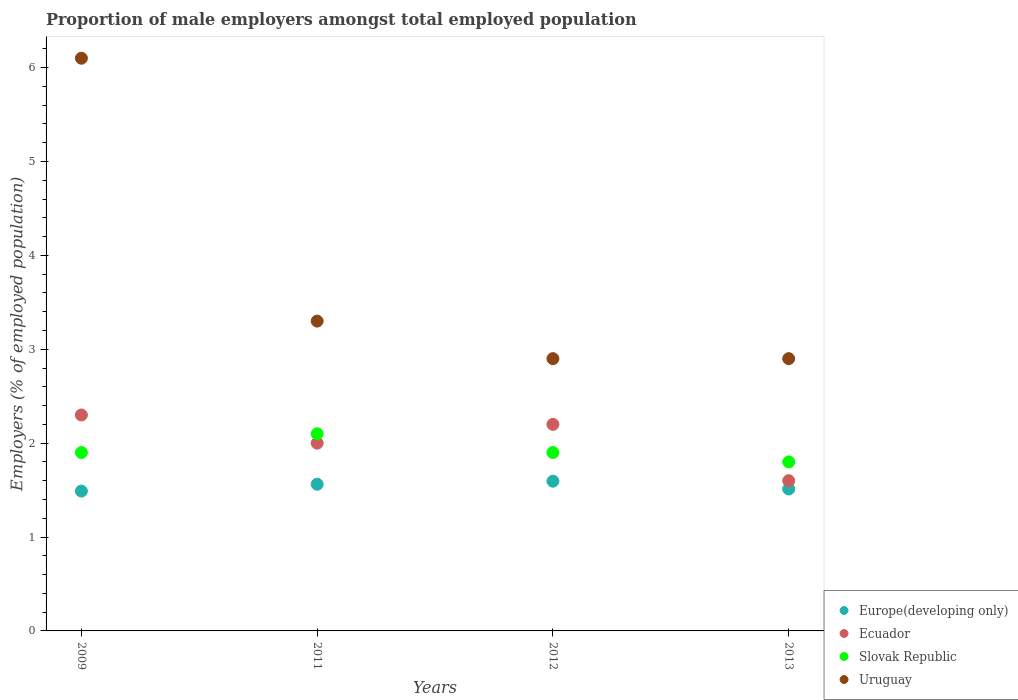What is the proportion of male employers in Uruguay in 2011?
Give a very brief answer. 3.3. Across all years, what is the maximum proportion of male employers in Ecuador?
Your response must be concise. 2.3. Across all years, what is the minimum proportion of male employers in Uruguay?
Provide a short and direct response. 2.9. In which year was the proportion of male employers in Slovak Republic maximum?
Your answer should be compact. 2011. In which year was the proportion of male employers in Ecuador minimum?
Keep it short and to the point. 2013. What is the total proportion of male employers in Uruguay in the graph?
Give a very brief answer. 15.2. What is the difference between the proportion of male employers in Europe(developing only) in 2009 and that in 2011?
Your answer should be compact. -0.07. What is the difference between the proportion of male employers in Slovak Republic in 2011 and the proportion of male employers in Ecuador in 2013?
Make the answer very short. 0.5. What is the average proportion of male employers in Slovak Republic per year?
Offer a very short reply. 1.92. In the year 2013, what is the difference between the proportion of male employers in Slovak Republic and proportion of male employers in Ecuador?
Your response must be concise. 0.2. What is the ratio of the proportion of male employers in Europe(developing only) in 2009 to that in 2013?
Offer a very short reply. 0.99. What is the difference between the highest and the second highest proportion of male employers in Uruguay?
Give a very brief answer. 2.8. What is the difference between the highest and the lowest proportion of male employers in Ecuador?
Ensure brevity in your answer.  0.7. Is the sum of the proportion of male employers in Ecuador in 2009 and 2012 greater than the maximum proportion of male employers in Slovak Republic across all years?
Your answer should be compact. Yes. Is it the case that in every year, the sum of the proportion of male employers in Slovak Republic and proportion of male employers in Ecuador  is greater than the sum of proportion of male employers in Uruguay and proportion of male employers in Europe(developing only)?
Ensure brevity in your answer.  No. Does the proportion of male employers in Slovak Republic monotonically increase over the years?
Keep it short and to the point. No. Is the proportion of male employers in Slovak Republic strictly less than the proportion of male employers in Europe(developing only) over the years?
Provide a succinct answer. No. How many dotlines are there?
Ensure brevity in your answer.  4. Are the values on the major ticks of Y-axis written in scientific E-notation?
Your answer should be very brief. No. Does the graph contain grids?
Keep it short and to the point. No. Where does the legend appear in the graph?
Make the answer very short. Bottom right. How many legend labels are there?
Offer a terse response. 4. What is the title of the graph?
Ensure brevity in your answer.  Proportion of male employers amongst total employed population. Does "Euro area" appear as one of the legend labels in the graph?
Ensure brevity in your answer.  No. What is the label or title of the Y-axis?
Your response must be concise. Employers (% of employed population). What is the Employers (% of employed population) in Europe(developing only) in 2009?
Make the answer very short. 1.49. What is the Employers (% of employed population) of Ecuador in 2009?
Provide a succinct answer. 2.3. What is the Employers (% of employed population) of Slovak Republic in 2009?
Make the answer very short. 1.9. What is the Employers (% of employed population) in Uruguay in 2009?
Offer a very short reply. 6.1. What is the Employers (% of employed population) in Europe(developing only) in 2011?
Your response must be concise. 1.56. What is the Employers (% of employed population) of Ecuador in 2011?
Offer a terse response. 2. What is the Employers (% of employed population) in Slovak Republic in 2011?
Provide a succinct answer. 2.1. What is the Employers (% of employed population) in Uruguay in 2011?
Ensure brevity in your answer.  3.3. What is the Employers (% of employed population) of Europe(developing only) in 2012?
Provide a short and direct response. 1.59. What is the Employers (% of employed population) in Ecuador in 2012?
Offer a very short reply. 2.2. What is the Employers (% of employed population) in Slovak Republic in 2012?
Offer a very short reply. 1.9. What is the Employers (% of employed population) in Uruguay in 2012?
Give a very brief answer. 2.9. What is the Employers (% of employed population) of Europe(developing only) in 2013?
Make the answer very short. 1.51. What is the Employers (% of employed population) in Ecuador in 2013?
Your answer should be very brief. 1.6. What is the Employers (% of employed population) of Slovak Republic in 2013?
Your answer should be compact. 1.8. What is the Employers (% of employed population) of Uruguay in 2013?
Your response must be concise. 2.9. Across all years, what is the maximum Employers (% of employed population) of Europe(developing only)?
Your answer should be very brief. 1.59. Across all years, what is the maximum Employers (% of employed population) of Ecuador?
Your answer should be compact. 2.3. Across all years, what is the maximum Employers (% of employed population) in Slovak Republic?
Offer a very short reply. 2.1. Across all years, what is the maximum Employers (% of employed population) of Uruguay?
Ensure brevity in your answer.  6.1. Across all years, what is the minimum Employers (% of employed population) of Europe(developing only)?
Provide a succinct answer. 1.49. Across all years, what is the minimum Employers (% of employed population) of Ecuador?
Your answer should be very brief. 1.6. Across all years, what is the minimum Employers (% of employed population) of Slovak Republic?
Keep it short and to the point. 1.8. Across all years, what is the minimum Employers (% of employed population) in Uruguay?
Your response must be concise. 2.9. What is the total Employers (% of employed population) in Europe(developing only) in the graph?
Give a very brief answer. 6.16. What is the total Employers (% of employed population) of Ecuador in the graph?
Your response must be concise. 8.1. What is the difference between the Employers (% of employed population) in Europe(developing only) in 2009 and that in 2011?
Make the answer very short. -0.07. What is the difference between the Employers (% of employed population) of Europe(developing only) in 2009 and that in 2012?
Your response must be concise. -0.11. What is the difference between the Employers (% of employed population) of Europe(developing only) in 2009 and that in 2013?
Your answer should be very brief. -0.02. What is the difference between the Employers (% of employed population) of Ecuador in 2009 and that in 2013?
Your answer should be compact. 0.7. What is the difference between the Employers (% of employed population) in Slovak Republic in 2009 and that in 2013?
Your answer should be very brief. 0.1. What is the difference between the Employers (% of employed population) in Uruguay in 2009 and that in 2013?
Give a very brief answer. 3.2. What is the difference between the Employers (% of employed population) in Europe(developing only) in 2011 and that in 2012?
Keep it short and to the point. -0.03. What is the difference between the Employers (% of employed population) in Ecuador in 2011 and that in 2012?
Offer a very short reply. -0.2. What is the difference between the Employers (% of employed population) in Slovak Republic in 2011 and that in 2012?
Make the answer very short. 0.2. What is the difference between the Employers (% of employed population) of Uruguay in 2011 and that in 2012?
Your response must be concise. 0.4. What is the difference between the Employers (% of employed population) of Europe(developing only) in 2011 and that in 2013?
Ensure brevity in your answer.  0.05. What is the difference between the Employers (% of employed population) of Slovak Republic in 2011 and that in 2013?
Provide a short and direct response. 0.3. What is the difference between the Employers (% of employed population) of Europe(developing only) in 2012 and that in 2013?
Your answer should be very brief. 0.08. What is the difference between the Employers (% of employed population) in Slovak Republic in 2012 and that in 2013?
Offer a terse response. 0.1. What is the difference between the Employers (% of employed population) of Uruguay in 2012 and that in 2013?
Keep it short and to the point. 0. What is the difference between the Employers (% of employed population) in Europe(developing only) in 2009 and the Employers (% of employed population) in Ecuador in 2011?
Your response must be concise. -0.51. What is the difference between the Employers (% of employed population) of Europe(developing only) in 2009 and the Employers (% of employed population) of Slovak Republic in 2011?
Provide a short and direct response. -0.61. What is the difference between the Employers (% of employed population) in Europe(developing only) in 2009 and the Employers (% of employed population) in Uruguay in 2011?
Your answer should be very brief. -1.81. What is the difference between the Employers (% of employed population) of Europe(developing only) in 2009 and the Employers (% of employed population) of Ecuador in 2012?
Offer a very short reply. -0.71. What is the difference between the Employers (% of employed population) of Europe(developing only) in 2009 and the Employers (% of employed population) of Slovak Republic in 2012?
Provide a short and direct response. -0.41. What is the difference between the Employers (% of employed population) in Europe(developing only) in 2009 and the Employers (% of employed population) in Uruguay in 2012?
Ensure brevity in your answer.  -1.41. What is the difference between the Employers (% of employed population) in Ecuador in 2009 and the Employers (% of employed population) in Slovak Republic in 2012?
Ensure brevity in your answer.  0.4. What is the difference between the Employers (% of employed population) in Slovak Republic in 2009 and the Employers (% of employed population) in Uruguay in 2012?
Make the answer very short. -1. What is the difference between the Employers (% of employed population) of Europe(developing only) in 2009 and the Employers (% of employed population) of Ecuador in 2013?
Provide a succinct answer. -0.11. What is the difference between the Employers (% of employed population) of Europe(developing only) in 2009 and the Employers (% of employed population) of Slovak Republic in 2013?
Your response must be concise. -0.31. What is the difference between the Employers (% of employed population) of Europe(developing only) in 2009 and the Employers (% of employed population) of Uruguay in 2013?
Offer a very short reply. -1.41. What is the difference between the Employers (% of employed population) in Ecuador in 2009 and the Employers (% of employed population) in Slovak Republic in 2013?
Keep it short and to the point. 0.5. What is the difference between the Employers (% of employed population) in Europe(developing only) in 2011 and the Employers (% of employed population) in Ecuador in 2012?
Give a very brief answer. -0.64. What is the difference between the Employers (% of employed population) of Europe(developing only) in 2011 and the Employers (% of employed population) of Slovak Republic in 2012?
Give a very brief answer. -0.34. What is the difference between the Employers (% of employed population) in Europe(developing only) in 2011 and the Employers (% of employed population) in Uruguay in 2012?
Make the answer very short. -1.34. What is the difference between the Employers (% of employed population) in Slovak Republic in 2011 and the Employers (% of employed population) in Uruguay in 2012?
Provide a succinct answer. -0.8. What is the difference between the Employers (% of employed population) in Europe(developing only) in 2011 and the Employers (% of employed population) in Ecuador in 2013?
Make the answer very short. -0.04. What is the difference between the Employers (% of employed population) in Europe(developing only) in 2011 and the Employers (% of employed population) in Slovak Republic in 2013?
Your answer should be compact. -0.24. What is the difference between the Employers (% of employed population) of Europe(developing only) in 2011 and the Employers (% of employed population) of Uruguay in 2013?
Give a very brief answer. -1.34. What is the difference between the Employers (% of employed population) of Ecuador in 2011 and the Employers (% of employed population) of Uruguay in 2013?
Make the answer very short. -0.9. What is the difference between the Employers (% of employed population) of Slovak Republic in 2011 and the Employers (% of employed population) of Uruguay in 2013?
Your answer should be compact. -0.8. What is the difference between the Employers (% of employed population) in Europe(developing only) in 2012 and the Employers (% of employed population) in Ecuador in 2013?
Make the answer very short. -0.01. What is the difference between the Employers (% of employed population) in Europe(developing only) in 2012 and the Employers (% of employed population) in Slovak Republic in 2013?
Provide a short and direct response. -0.21. What is the difference between the Employers (% of employed population) of Europe(developing only) in 2012 and the Employers (% of employed population) of Uruguay in 2013?
Give a very brief answer. -1.31. What is the difference between the Employers (% of employed population) of Ecuador in 2012 and the Employers (% of employed population) of Slovak Republic in 2013?
Ensure brevity in your answer.  0.4. What is the difference between the Employers (% of employed population) in Ecuador in 2012 and the Employers (% of employed population) in Uruguay in 2013?
Keep it short and to the point. -0.7. What is the average Employers (% of employed population) of Europe(developing only) per year?
Give a very brief answer. 1.54. What is the average Employers (% of employed population) of Ecuador per year?
Give a very brief answer. 2.02. What is the average Employers (% of employed population) in Slovak Republic per year?
Your answer should be very brief. 1.93. In the year 2009, what is the difference between the Employers (% of employed population) of Europe(developing only) and Employers (% of employed population) of Ecuador?
Offer a terse response. -0.81. In the year 2009, what is the difference between the Employers (% of employed population) of Europe(developing only) and Employers (% of employed population) of Slovak Republic?
Ensure brevity in your answer.  -0.41. In the year 2009, what is the difference between the Employers (% of employed population) in Europe(developing only) and Employers (% of employed population) in Uruguay?
Your answer should be compact. -4.61. In the year 2011, what is the difference between the Employers (% of employed population) of Europe(developing only) and Employers (% of employed population) of Ecuador?
Offer a very short reply. -0.44. In the year 2011, what is the difference between the Employers (% of employed population) of Europe(developing only) and Employers (% of employed population) of Slovak Republic?
Your response must be concise. -0.54. In the year 2011, what is the difference between the Employers (% of employed population) in Europe(developing only) and Employers (% of employed population) in Uruguay?
Your response must be concise. -1.74. In the year 2011, what is the difference between the Employers (% of employed population) in Ecuador and Employers (% of employed population) in Slovak Republic?
Offer a very short reply. -0.1. In the year 2011, what is the difference between the Employers (% of employed population) of Slovak Republic and Employers (% of employed population) of Uruguay?
Ensure brevity in your answer.  -1.2. In the year 2012, what is the difference between the Employers (% of employed population) of Europe(developing only) and Employers (% of employed population) of Ecuador?
Provide a short and direct response. -0.61. In the year 2012, what is the difference between the Employers (% of employed population) in Europe(developing only) and Employers (% of employed population) in Slovak Republic?
Give a very brief answer. -0.31. In the year 2012, what is the difference between the Employers (% of employed population) in Europe(developing only) and Employers (% of employed population) in Uruguay?
Keep it short and to the point. -1.31. In the year 2012, what is the difference between the Employers (% of employed population) in Slovak Republic and Employers (% of employed population) in Uruguay?
Your answer should be very brief. -1. In the year 2013, what is the difference between the Employers (% of employed population) in Europe(developing only) and Employers (% of employed population) in Ecuador?
Offer a terse response. -0.09. In the year 2013, what is the difference between the Employers (% of employed population) in Europe(developing only) and Employers (% of employed population) in Slovak Republic?
Offer a very short reply. -0.29. In the year 2013, what is the difference between the Employers (% of employed population) in Europe(developing only) and Employers (% of employed population) in Uruguay?
Ensure brevity in your answer.  -1.39. In the year 2013, what is the difference between the Employers (% of employed population) of Ecuador and Employers (% of employed population) of Uruguay?
Make the answer very short. -1.3. What is the ratio of the Employers (% of employed population) of Europe(developing only) in 2009 to that in 2011?
Make the answer very short. 0.95. What is the ratio of the Employers (% of employed population) in Ecuador in 2009 to that in 2011?
Your answer should be compact. 1.15. What is the ratio of the Employers (% of employed population) of Slovak Republic in 2009 to that in 2011?
Keep it short and to the point. 0.9. What is the ratio of the Employers (% of employed population) of Uruguay in 2009 to that in 2011?
Ensure brevity in your answer.  1.85. What is the ratio of the Employers (% of employed population) in Europe(developing only) in 2009 to that in 2012?
Offer a very short reply. 0.93. What is the ratio of the Employers (% of employed population) in Ecuador in 2009 to that in 2012?
Provide a short and direct response. 1.05. What is the ratio of the Employers (% of employed population) of Slovak Republic in 2009 to that in 2012?
Offer a very short reply. 1. What is the ratio of the Employers (% of employed population) of Uruguay in 2009 to that in 2012?
Give a very brief answer. 2.1. What is the ratio of the Employers (% of employed population) in Europe(developing only) in 2009 to that in 2013?
Ensure brevity in your answer.  0.99. What is the ratio of the Employers (% of employed population) in Ecuador in 2009 to that in 2013?
Offer a very short reply. 1.44. What is the ratio of the Employers (% of employed population) in Slovak Republic in 2009 to that in 2013?
Offer a very short reply. 1.06. What is the ratio of the Employers (% of employed population) of Uruguay in 2009 to that in 2013?
Offer a very short reply. 2.1. What is the ratio of the Employers (% of employed population) in Europe(developing only) in 2011 to that in 2012?
Offer a terse response. 0.98. What is the ratio of the Employers (% of employed population) in Slovak Republic in 2011 to that in 2012?
Provide a succinct answer. 1.11. What is the ratio of the Employers (% of employed population) of Uruguay in 2011 to that in 2012?
Give a very brief answer. 1.14. What is the ratio of the Employers (% of employed population) of Europe(developing only) in 2011 to that in 2013?
Your answer should be compact. 1.03. What is the ratio of the Employers (% of employed population) of Ecuador in 2011 to that in 2013?
Provide a succinct answer. 1.25. What is the ratio of the Employers (% of employed population) in Uruguay in 2011 to that in 2013?
Your answer should be compact. 1.14. What is the ratio of the Employers (% of employed population) of Europe(developing only) in 2012 to that in 2013?
Offer a terse response. 1.06. What is the ratio of the Employers (% of employed population) of Ecuador in 2012 to that in 2013?
Your response must be concise. 1.38. What is the ratio of the Employers (% of employed population) of Slovak Republic in 2012 to that in 2013?
Offer a terse response. 1.06. What is the difference between the highest and the second highest Employers (% of employed population) of Europe(developing only)?
Your answer should be compact. 0.03. What is the difference between the highest and the lowest Employers (% of employed population) in Europe(developing only)?
Ensure brevity in your answer.  0.11. What is the difference between the highest and the lowest Employers (% of employed population) in Ecuador?
Give a very brief answer. 0.7. What is the difference between the highest and the lowest Employers (% of employed population) of Slovak Republic?
Offer a very short reply. 0.3. What is the difference between the highest and the lowest Employers (% of employed population) in Uruguay?
Your answer should be very brief. 3.2. 